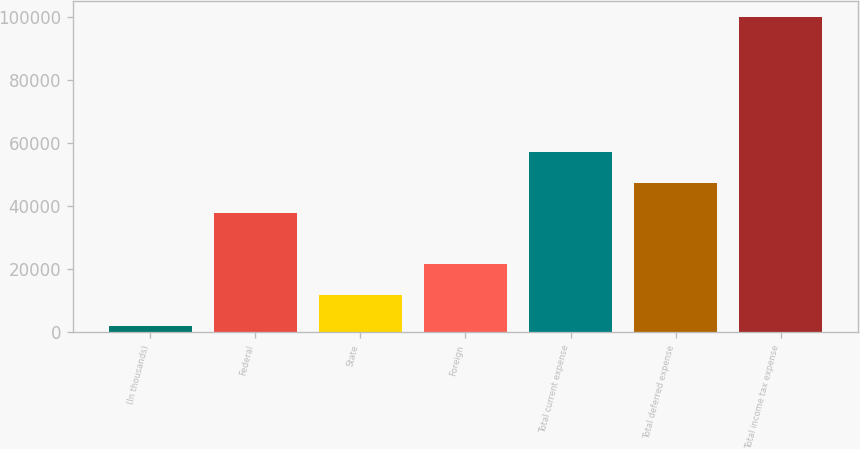<chart> <loc_0><loc_0><loc_500><loc_500><bar_chart><fcel>(In thousands)<fcel>Federal<fcel>State<fcel>Foreign<fcel>Total current expense<fcel>Total deferred expense<fcel>Total income tax expense<nl><fcel>2017<fcel>37708<fcel>11830.4<fcel>21643.8<fcel>57334.8<fcel>47521.4<fcel>100151<nl></chart> 